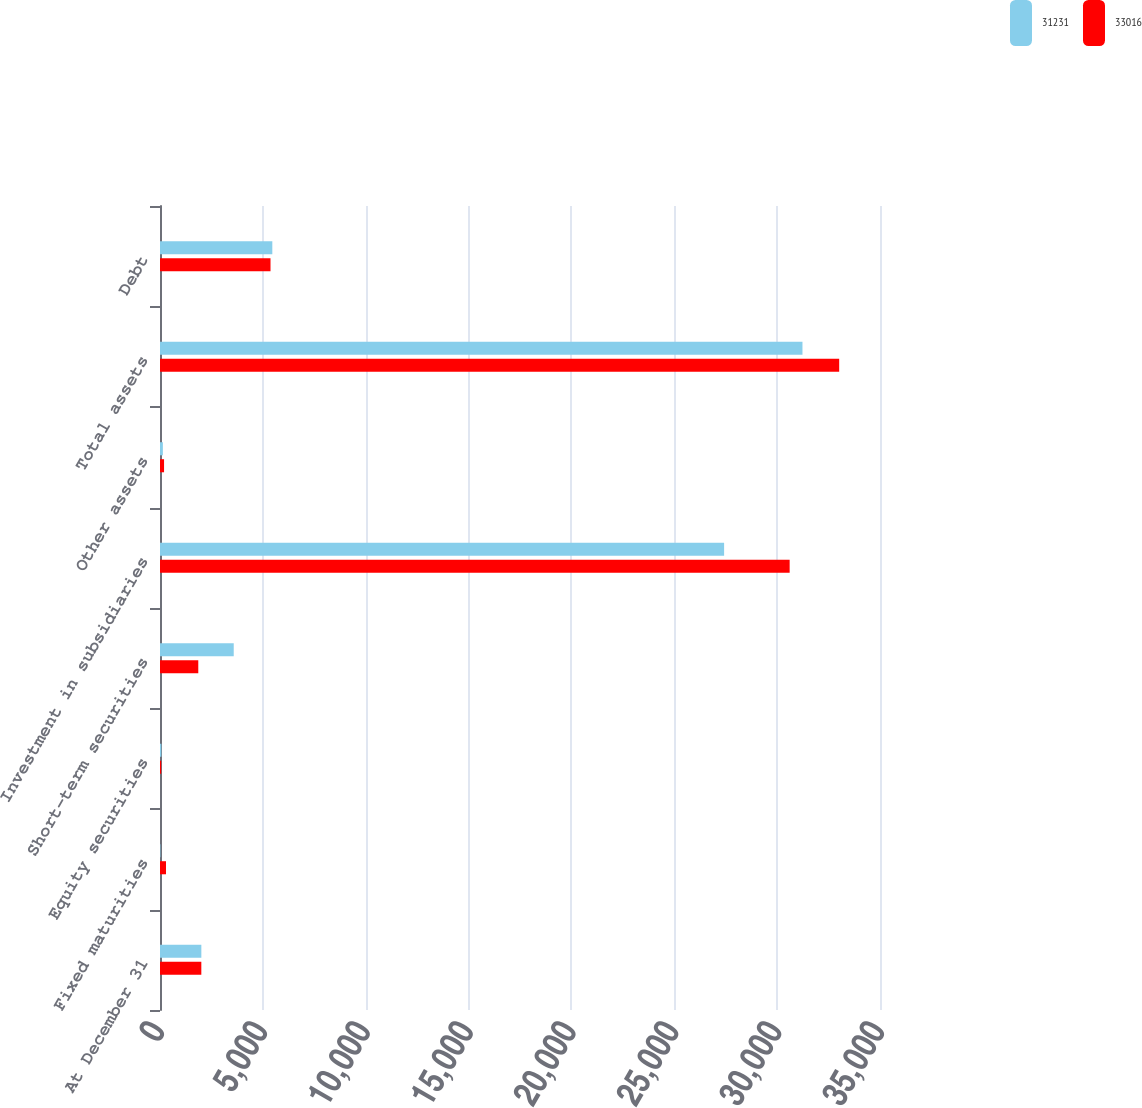Convert chart. <chart><loc_0><loc_0><loc_500><loc_500><stacked_bar_chart><ecel><fcel>At December 31<fcel>Fixed maturities<fcel>Equity securities<fcel>Short-term securities<fcel>Investment in subsidiaries<fcel>Other assets<fcel>Total assets<fcel>Debt<nl><fcel>31231<fcel>2010<fcel>20<fcel>66<fcel>3584<fcel>27422<fcel>139<fcel>31231<fcel>5460<nl><fcel>33016<fcel>2009<fcel>293<fcel>57<fcel>1861<fcel>30608<fcel>197<fcel>33016<fcel>5372<nl></chart> 